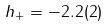<formula> <loc_0><loc_0><loc_500><loc_500>h _ { + } = - 2 . 2 ( 2 )</formula> 